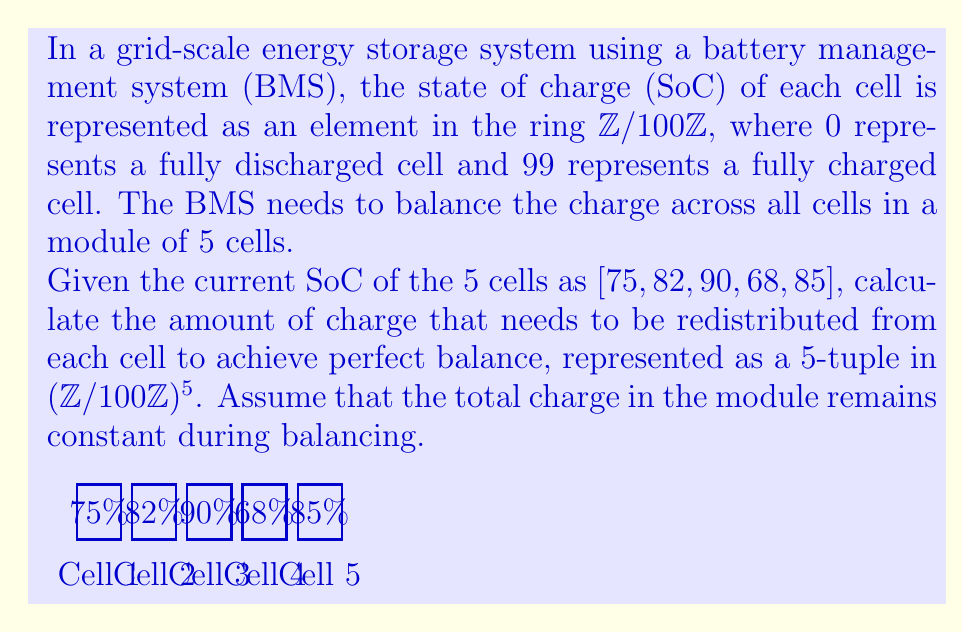Solve this math problem. Let's approach this step-by-step:

1) First, we need to calculate the total charge in the module:
   $75 + 82 + 90 + 68 + 85 = 400$

2) To achieve perfect balance, each cell should have the same charge. We can calculate this by dividing the total charge by the number of cells:
   $400 \div 5 = 80$

3) Now, we need to calculate how much charge needs to be redistributed for each cell. We'll subtract 80 from each cell's current charge:

   Cell 1: $75 - 80 = -5$
   Cell 2: $82 - 80 = 2$
   Cell 3: $90 - 80 = 10$
   Cell 4: $68 - 80 = -12$
   Cell 5: $85 - 80 = 5$

4) However, we're working in the ring $\mathbb{Z}/100\mathbb{Z}$, so we need to ensure all these values are non-negative and less than 100. We can do this by adding or subtracting 100 as needed:

   Cell 1: $-5 + 100 = 95$
   Cell 2: $2$ (no change needed)
   Cell 3: $10$ (no change needed)
   Cell 4: $-12 + 100 = 88$
   Cell 5: $5$ (no change needed)

5) Therefore, the amount of charge that needs to be redistributed from each cell is represented by the 5-tuple:

   $(95, 2, 10, 88, 5)$ in $(\mathbb{Z}/100\mathbb{Z})^5$

This tuple represents the charge that needs to be removed from each cell. A positive value means charge needs to be removed, while a value close to 100 (which is equivalent to a negative value in $\mathbb{Z}/100\mathbb{Z}$) means charge needs to be added.
Answer: $(95, 2, 10, 88, 5)$ 